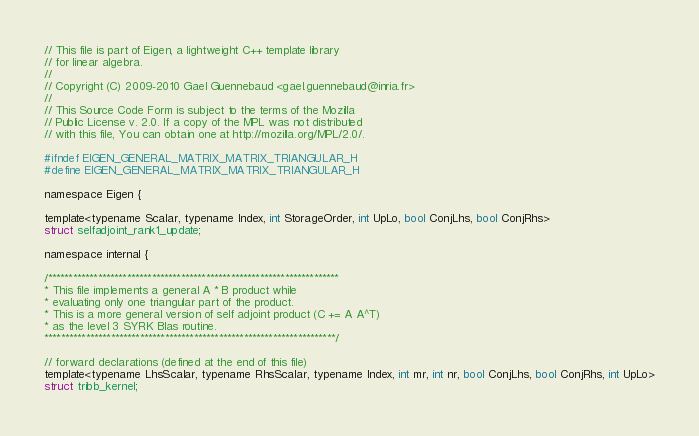<code> <loc_0><loc_0><loc_500><loc_500><_C_>// This file is part of Eigen, a lightweight C++ template library
// for linear algebra.
//
// Copyright (C) 2009-2010 Gael Guennebaud <gael.guennebaud@inria.fr>
//
// This Source Code Form is subject to the terms of the Mozilla
// Public License v. 2.0. If a copy of the MPL was not distributed
// with this file, You can obtain one at http://mozilla.org/MPL/2.0/.

#ifndef EIGEN_GENERAL_MATRIX_MATRIX_TRIANGULAR_H
#define EIGEN_GENERAL_MATRIX_MATRIX_TRIANGULAR_H

namespace Eigen { 

template<typename Scalar, typename Index, int StorageOrder, int UpLo, bool ConjLhs, bool ConjRhs>
struct selfadjoint_rank1_update;

namespace internal {

/**********************************************************************
* This file implements a general A * B product while
* evaluating only one triangular part of the product.
* This is a more general version of self adjoint product (C += A A^T)
* as the level 3 SYRK Blas routine.
**********************************************************************/

// forward declarations (defined at the end of this file)
template<typename LhsScalar, typename RhsScalar, typename Index, int mr, int nr, bool ConjLhs, bool ConjRhs, int UpLo>
struct tribb_kernel;</code> 